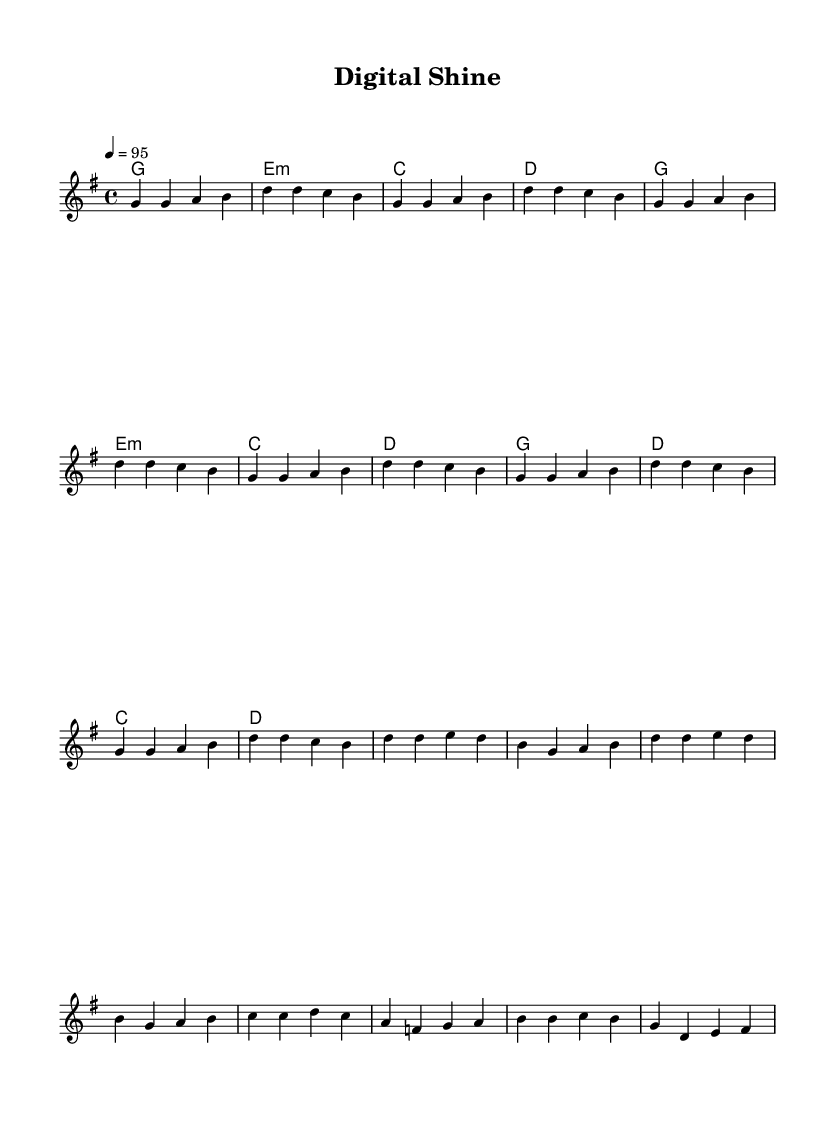What is the key signature of this music? The key signature is G major, which has one sharp (F#). You can determine this by looking at the key signature symbol located at the beginning of the staff.
Answer: G major What is the time signature of the music? The time signature is 4/4, indicated at the beginning of the score. This means there are four beats in each measure, and the quarter note gets one beat.
Answer: 4/4 What is the tempo marking of this piece? The tempo marking is quarter note = 95, shown at the start of the score. This indicates that the quarter note should be played at a speed of 95 beats per minute.
Answer: 95 How many measures are in the chorus section? The chorus section has four measures. You can count the measures by looking at the written music in the chorus section indicated by the melody and harmonies.
Answer: 4 What is the chord progression for the intro? The chord progression for the intro is G, E minor, C, D. You can find this by reading the chord names above the corresponding melody notes in the intro section.
Answer: G, E minor, C, D How many times is the verse melody repeated? The verse melody is repeated four times. This is evident from the repeated sections in the melody layout, which shows the same four-bar sequence repeated multiple times.
Answer: 4 What type of music is this piece categorized as? This piece is categorized as rap music. You derive this from the title "Digital Shine" and the thematic focus on online reputation management, which is typical of rap lyrics.
Answer: Rap 